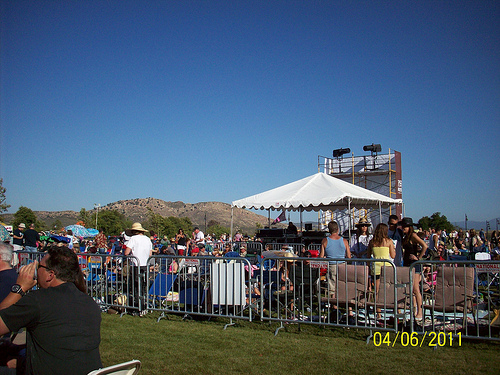<image>
Is there a tent behind the gate? Yes. From this viewpoint, the tent is positioned behind the gate, with the gate partially or fully occluding the tent. Where is the gate in relation to the chair? Is it behind the chair? No. The gate is not behind the chair. From this viewpoint, the gate appears to be positioned elsewhere in the scene. 